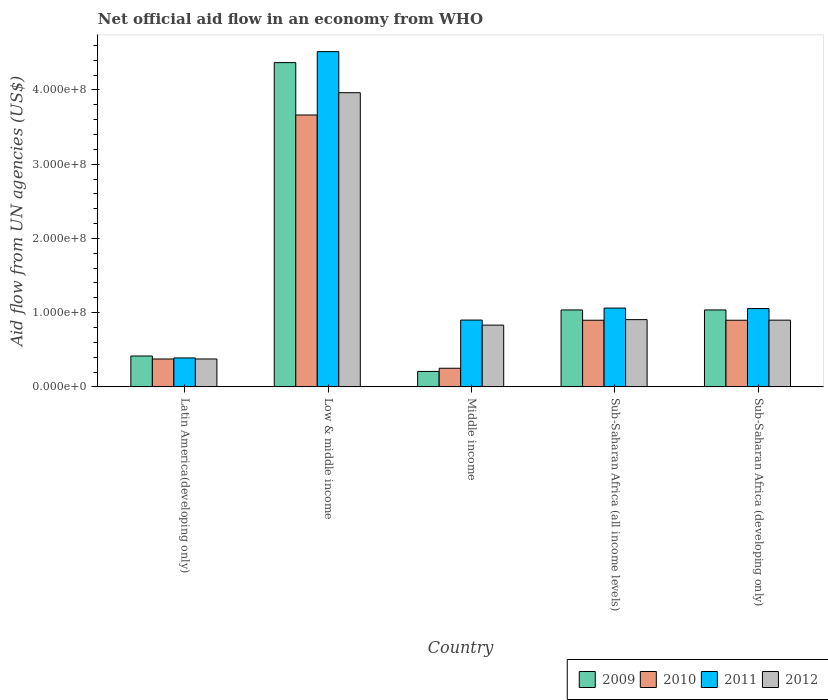Are the number of bars per tick equal to the number of legend labels?
Ensure brevity in your answer.  Yes. Are the number of bars on each tick of the X-axis equal?
Provide a succinct answer. Yes. How many bars are there on the 3rd tick from the left?
Keep it short and to the point. 4. What is the net official aid flow in 2011 in Sub-Saharan Africa (developing only)?
Provide a succinct answer. 1.05e+08. Across all countries, what is the maximum net official aid flow in 2009?
Provide a succinct answer. 4.37e+08. Across all countries, what is the minimum net official aid flow in 2012?
Give a very brief answer. 3.76e+07. In which country was the net official aid flow in 2011 minimum?
Offer a terse response. Latin America(developing only). What is the total net official aid flow in 2009 in the graph?
Provide a short and direct response. 7.06e+08. What is the difference between the net official aid flow in 2010 in Low & middle income and that in Sub-Saharan Africa (developing only)?
Offer a terse response. 2.76e+08. What is the difference between the net official aid flow in 2011 in Latin America(developing only) and the net official aid flow in 2010 in Sub-Saharan Africa (all income levels)?
Provide a succinct answer. -5.08e+07. What is the average net official aid flow in 2012 per country?
Offer a terse response. 1.39e+08. What is the difference between the net official aid flow of/in 2012 and net official aid flow of/in 2011 in Middle income?
Provide a succinct answer. -6.80e+06. What is the ratio of the net official aid flow in 2012 in Latin America(developing only) to that in Sub-Saharan Africa (all income levels)?
Ensure brevity in your answer.  0.41. Is the difference between the net official aid flow in 2012 in Latin America(developing only) and Middle income greater than the difference between the net official aid flow in 2011 in Latin America(developing only) and Middle income?
Your response must be concise. Yes. What is the difference between the highest and the second highest net official aid flow in 2009?
Provide a succinct answer. 3.33e+08. What is the difference between the highest and the lowest net official aid flow in 2011?
Your answer should be very brief. 4.13e+08. Is the sum of the net official aid flow in 2009 in Sub-Saharan Africa (all income levels) and Sub-Saharan Africa (developing only) greater than the maximum net official aid flow in 2011 across all countries?
Your answer should be compact. No. Is it the case that in every country, the sum of the net official aid flow in 2010 and net official aid flow in 2011 is greater than the sum of net official aid flow in 2009 and net official aid flow in 2012?
Provide a short and direct response. No. What does the 3rd bar from the left in Middle income represents?
Your answer should be compact. 2011. Are all the bars in the graph horizontal?
Your response must be concise. No. How many countries are there in the graph?
Provide a succinct answer. 5. Does the graph contain any zero values?
Provide a short and direct response. No. Does the graph contain grids?
Keep it short and to the point. No. How many legend labels are there?
Provide a succinct answer. 4. How are the legend labels stacked?
Provide a short and direct response. Horizontal. What is the title of the graph?
Your answer should be very brief. Net official aid flow in an economy from WHO. What is the label or title of the Y-axis?
Offer a terse response. Aid flow from UN agencies (US$). What is the Aid flow from UN agencies (US$) in 2009 in Latin America(developing only)?
Keep it short and to the point. 4.16e+07. What is the Aid flow from UN agencies (US$) in 2010 in Latin America(developing only)?
Keep it short and to the point. 3.76e+07. What is the Aid flow from UN agencies (US$) in 2011 in Latin America(developing only)?
Offer a terse response. 3.90e+07. What is the Aid flow from UN agencies (US$) in 2012 in Latin America(developing only)?
Offer a terse response. 3.76e+07. What is the Aid flow from UN agencies (US$) of 2009 in Low & middle income?
Your answer should be very brief. 4.37e+08. What is the Aid flow from UN agencies (US$) in 2010 in Low & middle income?
Provide a short and direct response. 3.66e+08. What is the Aid flow from UN agencies (US$) in 2011 in Low & middle income?
Keep it short and to the point. 4.52e+08. What is the Aid flow from UN agencies (US$) of 2012 in Low & middle income?
Ensure brevity in your answer.  3.96e+08. What is the Aid flow from UN agencies (US$) of 2009 in Middle income?
Provide a succinct answer. 2.08e+07. What is the Aid flow from UN agencies (US$) in 2010 in Middle income?
Provide a short and direct response. 2.51e+07. What is the Aid flow from UN agencies (US$) in 2011 in Middle income?
Your response must be concise. 9.00e+07. What is the Aid flow from UN agencies (US$) in 2012 in Middle income?
Offer a very short reply. 8.32e+07. What is the Aid flow from UN agencies (US$) in 2009 in Sub-Saharan Africa (all income levels)?
Make the answer very short. 1.04e+08. What is the Aid flow from UN agencies (US$) in 2010 in Sub-Saharan Africa (all income levels)?
Ensure brevity in your answer.  8.98e+07. What is the Aid flow from UN agencies (US$) in 2011 in Sub-Saharan Africa (all income levels)?
Make the answer very short. 1.06e+08. What is the Aid flow from UN agencies (US$) in 2012 in Sub-Saharan Africa (all income levels)?
Your response must be concise. 9.06e+07. What is the Aid flow from UN agencies (US$) of 2009 in Sub-Saharan Africa (developing only)?
Keep it short and to the point. 1.04e+08. What is the Aid flow from UN agencies (US$) of 2010 in Sub-Saharan Africa (developing only)?
Offer a very short reply. 8.98e+07. What is the Aid flow from UN agencies (US$) of 2011 in Sub-Saharan Africa (developing only)?
Provide a succinct answer. 1.05e+08. What is the Aid flow from UN agencies (US$) in 2012 in Sub-Saharan Africa (developing only)?
Offer a very short reply. 8.98e+07. Across all countries, what is the maximum Aid flow from UN agencies (US$) in 2009?
Provide a succinct answer. 4.37e+08. Across all countries, what is the maximum Aid flow from UN agencies (US$) in 2010?
Keep it short and to the point. 3.66e+08. Across all countries, what is the maximum Aid flow from UN agencies (US$) of 2011?
Your answer should be very brief. 4.52e+08. Across all countries, what is the maximum Aid flow from UN agencies (US$) in 2012?
Offer a very short reply. 3.96e+08. Across all countries, what is the minimum Aid flow from UN agencies (US$) of 2009?
Ensure brevity in your answer.  2.08e+07. Across all countries, what is the minimum Aid flow from UN agencies (US$) of 2010?
Give a very brief answer. 2.51e+07. Across all countries, what is the minimum Aid flow from UN agencies (US$) in 2011?
Give a very brief answer. 3.90e+07. Across all countries, what is the minimum Aid flow from UN agencies (US$) in 2012?
Offer a very short reply. 3.76e+07. What is the total Aid flow from UN agencies (US$) in 2009 in the graph?
Keep it short and to the point. 7.06e+08. What is the total Aid flow from UN agencies (US$) in 2010 in the graph?
Provide a succinct answer. 6.08e+08. What is the total Aid flow from UN agencies (US$) in 2011 in the graph?
Ensure brevity in your answer.  7.92e+08. What is the total Aid flow from UN agencies (US$) of 2012 in the graph?
Give a very brief answer. 6.97e+08. What is the difference between the Aid flow from UN agencies (US$) in 2009 in Latin America(developing only) and that in Low & middle income?
Your answer should be very brief. -3.95e+08. What is the difference between the Aid flow from UN agencies (US$) in 2010 in Latin America(developing only) and that in Low & middle income?
Your answer should be very brief. -3.29e+08. What is the difference between the Aid flow from UN agencies (US$) in 2011 in Latin America(developing only) and that in Low & middle income?
Ensure brevity in your answer.  -4.13e+08. What is the difference between the Aid flow from UN agencies (US$) of 2012 in Latin America(developing only) and that in Low & middle income?
Ensure brevity in your answer.  -3.59e+08. What is the difference between the Aid flow from UN agencies (US$) of 2009 in Latin America(developing only) and that in Middle income?
Give a very brief answer. 2.08e+07. What is the difference between the Aid flow from UN agencies (US$) in 2010 in Latin America(developing only) and that in Middle income?
Your answer should be compact. 1.25e+07. What is the difference between the Aid flow from UN agencies (US$) of 2011 in Latin America(developing only) and that in Middle income?
Provide a succinct answer. -5.10e+07. What is the difference between the Aid flow from UN agencies (US$) of 2012 in Latin America(developing only) and that in Middle income?
Ensure brevity in your answer.  -4.56e+07. What is the difference between the Aid flow from UN agencies (US$) of 2009 in Latin America(developing only) and that in Sub-Saharan Africa (all income levels)?
Your answer should be compact. -6.20e+07. What is the difference between the Aid flow from UN agencies (US$) in 2010 in Latin America(developing only) and that in Sub-Saharan Africa (all income levels)?
Your answer should be very brief. -5.22e+07. What is the difference between the Aid flow from UN agencies (US$) in 2011 in Latin America(developing only) and that in Sub-Saharan Africa (all income levels)?
Provide a succinct answer. -6.72e+07. What is the difference between the Aid flow from UN agencies (US$) in 2012 in Latin America(developing only) and that in Sub-Saharan Africa (all income levels)?
Make the answer very short. -5.30e+07. What is the difference between the Aid flow from UN agencies (US$) in 2009 in Latin America(developing only) and that in Sub-Saharan Africa (developing only)?
Offer a terse response. -6.20e+07. What is the difference between the Aid flow from UN agencies (US$) in 2010 in Latin America(developing only) and that in Sub-Saharan Africa (developing only)?
Your response must be concise. -5.22e+07. What is the difference between the Aid flow from UN agencies (US$) of 2011 in Latin America(developing only) and that in Sub-Saharan Africa (developing only)?
Provide a succinct answer. -6.65e+07. What is the difference between the Aid flow from UN agencies (US$) of 2012 in Latin America(developing only) and that in Sub-Saharan Africa (developing only)?
Provide a succinct answer. -5.23e+07. What is the difference between the Aid flow from UN agencies (US$) in 2009 in Low & middle income and that in Middle income?
Give a very brief answer. 4.16e+08. What is the difference between the Aid flow from UN agencies (US$) of 2010 in Low & middle income and that in Middle income?
Make the answer very short. 3.41e+08. What is the difference between the Aid flow from UN agencies (US$) of 2011 in Low & middle income and that in Middle income?
Your answer should be compact. 3.62e+08. What is the difference between the Aid flow from UN agencies (US$) of 2012 in Low & middle income and that in Middle income?
Your response must be concise. 3.13e+08. What is the difference between the Aid flow from UN agencies (US$) in 2009 in Low & middle income and that in Sub-Saharan Africa (all income levels)?
Your answer should be compact. 3.33e+08. What is the difference between the Aid flow from UN agencies (US$) of 2010 in Low & middle income and that in Sub-Saharan Africa (all income levels)?
Your answer should be compact. 2.76e+08. What is the difference between the Aid flow from UN agencies (US$) in 2011 in Low & middle income and that in Sub-Saharan Africa (all income levels)?
Make the answer very short. 3.45e+08. What is the difference between the Aid flow from UN agencies (US$) in 2012 in Low & middle income and that in Sub-Saharan Africa (all income levels)?
Provide a short and direct response. 3.06e+08. What is the difference between the Aid flow from UN agencies (US$) of 2009 in Low & middle income and that in Sub-Saharan Africa (developing only)?
Offer a terse response. 3.33e+08. What is the difference between the Aid flow from UN agencies (US$) of 2010 in Low & middle income and that in Sub-Saharan Africa (developing only)?
Offer a terse response. 2.76e+08. What is the difference between the Aid flow from UN agencies (US$) of 2011 in Low & middle income and that in Sub-Saharan Africa (developing only)?
Your answer should be very brief. 3.46e+08. What is the difference between the Aid flow from UN agencies (US$) in 2012 in Low & middle income and that in Sub-Saharan Africa (developing only)?
Provide a short and direct response. 3.06e+08. What is the difference between the Aid flow from UN agencies (US$) in 2009 in Middle income and that in Sub-Saharan Africa (all income levels)?
Your response must be concise. -8.28e+07. What is the difference between the Aid flow from UN agencies (US$) in 2010 in Middle income and that in Sub-Saharan Africa (all income levels)?
Offer a terse response. -6.47e+07. What is the difference between the Aid flow from UN agencies (US$) in 2011 in Middle income and that in Sub-Saharan Africa (all income levels)?
Offer a very short reply. -1.62e+07. What is the difference between the Aid flow from UN agencies (US$) in 2012 in Middle income and that in Sub-Saharan Africa (all income levels)?
Your answer should be very brief. -7.39e+06. What is the difference between the Aid flow from UN agencies (US$) of 2009 in Middle income and that in Sub-Saharan Africa (developing only)?
Provide a succinct answer. -8.28e+07. What is the difference between the Aid flow from UN agencies (US$) in 2010 in Middle income and that in Sub-Saharan Africa (developing only)?
Offer a very short reply. -6.47e+07. What is the difference between the Aid flow from UN agencies (US$) of 2011 in Middle income and that in Sub-Saharan Africa (developing only)?
Your answer should be very brief. -1.55e+07. What is the difference between the Aid flow from UN agencies (US$) of 2012 in Middle income and that in Sub-Saharan Africa (developing only)?
Provide a short and direct response. -6.67e+06. What is the difference between the Aid flow from UN agencies (US$) in 2009 in Sub-Saharan Africa (all income levels) and that in Sub-Saharan Africa (developing only)?
Your response must be concise. 0. What is the difference between the Aid flow from UN agencies (US$) in 2010 in Sub-Saharan Africa (all income levels) and that in Sub-Saharan Africa (developing only)?
Give a very brief answer. 0. What is the difference between the Aid flow from UN agencies (US$) in 2011 in Sub-Saharan Africa (all income levels) and that in Sub-Saharan Africa (developing only)?
Your answer should be compact. 6.70e+05. What is the difference between the Aid flow from UN agencies (US$) in 2012 in Sub-Saharan Africa (all income levels) and that in Sub-Saharan Africa (developing only)?
Keep it short and to the point. 7.20e+05. What is the difference between the Aid flow from UN agencies (US$) in 2009 in Latin America(developing only) and the Aid flow from UN agencies (US$) in 2010 in Low & middle income?
Ensure brevity in your answer.  -3.25e+08. What is the difference between the Aid flow from UN agencies (US$) of 2009 in Latin America(developing only) and the Aid flow from UN agencies (US$) of 2011 in Low & middle income?
Ensure brevity in your answer.  -4.10e+08. What is the difference between the Aid flow from UN agencies (US$) of 2009 in Latin America(developing only) and the Aid flow from UN agencies (US$) of 2012 in Low & middle income?
Your answer should be very brief. -3.55e+08. What is the difference between the Aid flow from UN agencies (US$) in 2010 in Latin America(developing only) and the Aid flow from UN agencies (US$) in 2011 in Low & middle income?
Ensure brevity in your answer.  -4.14e+08. What is the difference between the Aid flow from UN agencies (US$) in 2010 in Latin America(developing only) and the Aid flow from UN agencies (US$) in 2012 in Low & middle income?
Make the answer very short. -3.59e+08. What is the difference between the Aid flow from UN agencies (US$) of 2011 in Latin America(developing only) and the Aid flow from UN agencies (US$) of 2012 in Low & middle income?
Ensure brevity in your answer.  -3.57e+08. What is the difference between the Aid flow from UN agencies (US$) in 2009 in Latin America(developing only) and the Aid flow from UN agencies (US$) in 2010 in Middle income?
Give a very brief answer. 1.65e+07. What is the difference between the Aid flow from UN agencies (US$) of 2009 in Latin America(developing only) and the Aid flow from UN agencies (US$) of 2011 in Middle income?
Give a very brief answer. -4.84e+07. What is the difference between the Aid flow from UN agencies (US$) in 2009 in Latin America(developing only) and the Aid flow from UN agencies (US$) in 2012 in Middle income?
Keep it short and to the point. -4.16e+07. What is the difference between the Aid flow from UN agencies (US$) in 2010 in Latin America(developing only) and the Aid flow from UN agencies (US$) in 2011 in Middle income?
Provide a short and direct response. -5.24e+07. What is the difference between the Aid flow from UN agencies (US$) of 2010 in Latin America(developing only) and the Aid flow from UN agencies (US$) of 2012 in Middle income?
Provide a short and direct response. -4.56e+07. What is the difference between the Aid flow from UN agencies (US$) in 2011 in Latin America(developing only) and the Aid flow from UN agencies (US$) in 2012 in Middle income?
Your answer should be compact. -4.42e+07. What is the difference between the Aid flow from UN agencies (US$) of 2009 in Latin America(developing only) and the Aid flow from UN agencies (US$) of 2010 in Sub-Saharan Africa (all income levels)?
Your answer should be compact. -4.82e+07. What is the difference between the Aid flow from UN agencies (US$) in 2009 in Latin America(developing only) and the Aid flow from UN agencies (US$) in 2011 in Sub-Saharan Africa (all income levels)?
Ensure brevity in your answer.  -6.46e+07. What is the difference between the Aid flow from UN agencies (US$) of 2009 in Latin America(developing only) and the Aid flow from UN agencies (US$) of 2012 in Sub-Saharan Africa (all income levels)?
Offer a terse response. -4.90e+07. What is the difference between the Aid flow from UN agencies (US$) in 2010 in Latin America(developing only) and the Aid flow from UN agencies (US$) in 2011 in Sub-Saharan Africa (all income levels)?
Ensure brevity in your answer.  -6.86e+07. What is the difference between the Aid flow from UN agencies (US$) of 2010 in Latin America(developing only) and the Aid flow from UN agencies (US$) of 2012 in Sub-Saharan Africa (all income levels)?
Offer a terse response. -5.30e+07. What is the difference between the Aid flow from UN agencies (US$) of 2011 in Latin America(developing only) and the Aid flow from UN agencies (US$) of 2012 in Sub-Saharan Africa (all income levels)?
Provide a succinct answer. -5.16e+07. What is the difference between the Aid flow from UN agencies (US$) in 2009 in Latin America(developing only) and the Aid flow from UN agencies (US$) in 2010 in Sub-Saharan Africa (developing only)?
Offer a very short reply. -4.82e+07. What is the difference between the Aid flow from UN agencies (US$) of 2009 in Latin America(developing only) and the Aid flow from UN agencies (US$) of 2011 in Sub-Saharan Africa (developing only)?
Offer a terse response. -6.39e+07. What is the difference between the Aid flow from UN agencies (US$) of 2009 in Latin America(developing only) and the Aid flow from UN agencies (US$) of 2012 in Sub-Saharan Africa (developing only)?
Your response must be concise. -4.83e+07. What is the difference between the Aid flow from UN agencies (US$) in 2010 in Latin America(developing only) and the Aid flow from UN agencies (US$) in 2011 in Sub-Saharan Africa (developing only)?
Provide a succinct answer. -6.79e+07. What is the difference between the Aid flow from UN agencies (US$) of 2010 in Latin America(developing only) and the Aid flow from UN agencies (US$) of 2012 in Sub-Saharan Africa (developing only)?
Offer a terse response. -5.23e+07. What is the difference between the Aid flow from UN agencies (US$) in 2011 in Latin America(developing only) and the Aid flow from UN agencies (US$) in 2012 in Sub-Saharan Africa (developing only)?
Ensure brevity in your answer.  -5.09e+07. What is the difference between the Aid flow from UN agencies (US$) in 2009 in Low & middle income and the Aid flow from UN agencies (US$) in 2010 in Middle income?
Provide a succinct answer. 4.12e+08. What is the difference between the Aid flow from UN agencies (US$) of 2009 in Low & middle income and the Aid flow from UN agencies (US$) of 2011 in Middle income?
Provide a succinct answer. 3.47e+08. What is the difference between the Aid flow from UN agencies (US$) in 2009 in Low & middle income and the Aid flow from UN agencies (US$) in 2012 in Middle income?
Your answer should be compact. 3.54e+08. What is the difference between the Aid flow from UN agencies (US$) of 2010 in Low & middle income and the Aid flow from UN agencies (US$) of 2011 in Middle income?
Make the answer very short. 2.76e+08. What is the difference between the Aid flow from UN agencies (US$) in 2010 in Low & middle income and the Aid flow from UN agencies (US$) in 2012 in Middle income?
Offer a very short reply. 2.83e+08. What is the difference between the Aid flow from UN agencies (US$) in 2011 in Low & middle income and the Aid flow from UN agencies (US$) in 2012 in Middle income?
Offer a very short reply. 3.68e+08. What is the difference between the Aid flow from UN agencies (US$) of 2009 in Low & middle income and the Aid flow from UN agencies (US$) of 2010 in Sub-Saharan Africa (all income levels)?
Offer a very short reply. 3.47e+08. What is the difference between the Aid flow from UN agencies (US$) of 2009 in Low & middle income and the Aid flow from UN agencies (US$) of 2011 in Sub-Saharan Africa (all income levels)?
Provide a succinct answer. 3.31e+08. What is the difference between the Aid flow from UN agencies (US$) in 2009 in Low & middle income and the Aid flow from UN agencies (US$) in 2012 in Sub-Saharan Africa (all income levels)?
Provide a short and direct response. 3.46e+08. What is the difference between the Aid flow from UN agencies (US$) of 2010 in Low & middle income and the Aid flow from UN agencies (US$) of 2011 in Sub-Saharan Africa (all income levels)?
Keep it short and to the point. 2.60e+08. What is the difference between the Aid flow from UN agencies (US$) in 2010 in Low & middle income and the Aid flow from UN agencies (US$) in 2012 in Sub-Saharan Africa (all income levels)?
Your response must be concise. 2.76e+08. What is the difference between the Aid flow from UN agencies (US$) of 2011 in Low & middle income and the Aid flow from UN agencies (US$) of 2012 in Sub-Saharan Africa (all income levels)?
Provide a short and direct response. 3.61e+08. What is the difference between the Aid flow from UN agencies (US$) of 2009 in Low & middle income and the Aid flow from UN agencies (US$) of 2010 in Sub-Saharan Africa (developing only)?
Offer a terse response. 3.47e+08. What is the difference between the Aid flow from UN agencies (US$) of 2009 in Low & middle income and the Aid flow from UN agencies (US$) of 2011 in Sub-Saharan Africa (developing only)?
Provide a succinct answer. 3.31e+08. What is the difference between the Aid flow from UN agencies (US$) in 2009 in Low & middle income and the Aid flow from UN agencies (US$) in 2012 in Sub-Saharan Africa (developing only)?
Offer a terse response. 3.47e+08. What is the difference between the Aid flow from UN agencies (US$) in 2010 in Low & middle income and the Aid flow from UN agencies (US$) in 2011 in Sub-Saharan Africa (developing only)?
Your answer should be very brief. 2.61e+08. What is the difference between the Aid flow from UN agencies (US$) of 2010 in Low & middle income and the Aid flow from UN agencies (US$) of 2012 in Sub-Saharan Africa (developing only)?
Offer a very short reply. 2.76e+08. What is the difference between the Aid flow from UN agencies (US$) in 2011 in Low & middle income and the Aid flow from UN agencies (US$) in 2012 in Sub-Saharan Africa (developing only)?
Keep it short and to the point. 3.62e+08. What is the difference between the Aid flow from UN agencies (US$) in 2009 in Middle income and the Aid flow from UN agencies (US$) in 2010 in Sub-Saharan Africa (all income levels)?
Ensure brevity in your answer.  -6.90e+07. What is the difference between the Aid flow from UN agencies (US$) in 2009 in Middle income and the Aid flow from UN agencies (US$) in 2011 in Sub-Saharan Africa (all income levels)?
Provide a short and direct response. -8.54e+07. What is the difference between the Aid flow from UN agencies (US$) in 2009 in Middle income and the Aid flow from UN agencies (US$) in 2012 in Sub-Saharan Africa (all income levels)?
Provide a short and direct response. -6.98e+07. What is the difference between the Aid flow from UN agencies (US$) in 2010 in Middle income and the Aid flow from UN agencies (US$) in 2011 in Sub-Saharan Africa (all income levels)?
Provide a short and direct response. -8.11e+07. What is the difference between the Aid flow from UN agencies (US$) of 2010 in Middle income and the Aid flow from UN agencies (US$) of 2012 in Sub-Saharan Africa (all income levels)?
Your answer should be very brief. -6.55e+07. What is the difference between the Aid flow from UN agencies (US$) of 2011 in Middle income and the Aid flow from UN agencies (US$) of 2012 in Sub-Saharan Africa (all income levels)?
Offer a very short reply. -5.90e+05. What is the difference between the Aid flow from UN agencies (US$) of 2009 in Middle income and the Aid flow from UN agencies (US$) of 2010 in Sub-Saharan Africa (developing only)?
Offer a terse response. -6.90e+07. What is the difference between the Aid flow from UN agencies (US$) in 2009 in Middle income and the Aid flow from UN agencies (US$) in 2011 in Sub-Saharan Africa (developing only)?
Your answer should be compact. -8.47e+07. What is the difference between the Aid flow from UN agencies (US$) of 2009 in Middle income and the Aid flow from UN agencies (US$) of 2012 in Sub-Saharan Africa (developing only)?
Offer a very short reply. -6.90e+07. What is the difference between the Aid flow from UN agencies (US$) of 2010 in Middle income and the Aid flow from UN agencies (US$) of 2011 in Sub-Saharan Africa (developing only)?
Your answer should be compact. -8.04e+07. What is the difference between the Aid flow from UN agencies (US$) of 2010 in Middle income and the Aid flow from UN agencies (US$) of 2012 in Sub-Saharan Africa (developing only)?
Offer a terse response. -6.48e+07. What is the difference between the Aid flow from UN agencies (US$) in 2009 in Sub-Saharan Africa (all income levels) and the Aid flow from UN agencies (US$) in 2010 in Sub-Saharan Africa (developing only)?
Your answer should be compact. 1.39e+07. What is the difference between the Aid flow from UN agencies (US$) in 2009 in Sub-Saharan Africa (all income levels) and the Aid flow from UN agencies (US$) in 2011 in Sub-Saharan Africa (developing only)?
Keep it short and to the point. -1.86e+06. What is the difference between the Aid flow from UN agencies (US$) of 2009 in Sub-Saharan Africa (all income levels) and the Aid flow from UN agencies (US$) of 2012 in Sub-Saharan Africa (developing only)?
Your answer should be very brief. 1.38e+07. What is the difference between the Aid flow from UN agencies (US$) of 2010 in Sub-Saharan Africa (all income levels) and the Aid flow from UN agencies (US$) of 2011 in Sub-Saharan Africa (developing only)?
Provide a succinct answer. -1.57e+07. What is the difference between the Aid flow from UN agencies (US$) of 2010 in Sub-Saharan Africa (all income levels) and the Aid flow from UN agencies (US$) of 2012 in Sub-Saharan Africa (developing only)?
Ensure brevity in your answer.  -9.00e+04. What is the difference between the Aid flow from UN agencies (US$) of 2011 in Sub-Saharan Africa (all income levels) and the Aid flow from UN agencies (US$) of 2012 in Sub-Saharan Africa (developing only)?
Keep it short and to the point. 1.63e+07. What is the average Aid flow from UN agencies (US$) in 2009 per country?
Keep it short and to the point. 1.41e+08. What is the average Aid flow from UN agencies (US$) in 2010 per country?
Provide a short and direct response. 1.22e+08. What is the average Aid flow from UN agencies (US$) of 2011 per country?
Make the answer very short. 1.58e+08. What is the average Aid flow from UN agencies (US$) in 2012 per country?
Offer a terse response. 1.39e+08. What is the difference between the Aid flow from UN agencies (US$) in 2009 and Aid flow from UN agencies (US$) in 2010 in Latin America(developing only)?
Offer a terse response. 4.01e+06. What is the difference between the Aid flow from UN agencies (US$) in 2009 and Aid flow from UN agencies (US$) in 2011 in Latin America(developing only)?
Your answer should be very brief. 2.59e+06. What is the difference between the Aid flow from UN agencies (US$) in 2009 and Aid flow from UN agencies (US$) in 2012 in Latin America(developing only)?
Your response must be concise. 3.99e+06. What is the difference between the Aid flow from UN agencies (US$) of 2010 and Aid flow from UN agencies (US$) of 2011 in Latin America(developing only)?
Provide a succinct answer. -1.42e+06. What is the difference between the Aid flow from UN agencies (US$) of 2010 and Aid flow from UN agencies (US$) of 2012 in Latin America(developing only)?
Provide a succinct answer. -2.00e+04. What is the difference between the Aid flow from UN agencies (US$) of 2011 and Aid flow from UN agencies (US$) of 2012 in Latin America(developing only)?
Make the answer very short. 1.40e+06. What is the difference between the Aid flow from UN agencies (US$) of 2009 and Aid flow from UN agencies (US$) of 2010 in Low & middle income?
Give a very brief answer. 7.06e+07. What is the difference between the Aid flow from UN agencies (US$) in 2009 and Aid flow from UN agencies (US$) in 2011 in Low & middle income?
Give a very brief answer. -1.48e+07. What is the difference between the Aid flow from UN agencies (US$) of 2009 and Aid flow from UN agencies (US$) of 2012 in Low & middle income?
Your answer should be very brief. 4.05e+07. What is the difference between the Aid flow from UN agencies (US$) of 2010 and Aid flow from UN agencies (US$) of 2011 in Low & middle income?
Offer a very short reply. -8.54e+07. What is the difference between the Aid flow from UN agencies (US$) in 2010 and Aid flow from UN agencies (US$) in 2012 in Low & middle income?
Your answer should be compact. -3.00e+07. What is the difference between the Aid flow from UN agencies (US$) in 2011 and Aid flow from UN agencies (US$) in 2012 in Low & middle income?
Give a very brief answer. 5.53e+07. What is the difference between the Aid flow from UN agencies (US$) of 2009 and Aid flow from UN agencies (US$) of 2010 in Middle income?
Your response must be concise. -4.27e+06. What is the difference between the Aid flow from UN agencies (US$) of 2009 and Aid flow from UN agencies (US$) of 2011 in Middle income?
Offer a terse response. -6.92e+07. What is the difference between the Aid flow from UN agencies (US$) of 2009 and Aid flow from UN agencies (US$) of 2012 in Middle income?
Ensure brevity in your answer.  -6.24e+07. What is the difference between the Aid flow from UN agencies (US$) of 2010 and Aid flow from UN agencies (US$) of 2011 in Middle income?
Your answer should be very brief. -6.49e+07. What is the difference between the Aid flow from UN agencies (US$) in 2010 and Aid flow from UN agencies (US$) in 2012 in Middle income?
Your answer should be very brief. -5.81e+07. What is the difference between the Aid flow from UN agencies (US$) of 2011 and Aid flow from UN agencies (US$) of 2012 in Middle income?
Your answer should be very brief. 6.80e+06. What is the difference between the Aid flow from UN agencies (US$) of 2009 and Aid flow from UN agencies (US$) of 2010 in Sub-Saharan Africa (all income levels)?
Your answer should be very brief. 1.39e+07. What is the difference between the Aid flow from UN agencies (US$) of 2009 and Aid flow from UN agencies (US$) of 2011 in Sub-Saharan Africa (all income levels)?
Make the answer very short. -2.53e+06. What is the difference between the Aid flow from UN agencies (US$) in 2009 and Aid flow from UN agencies (US$) in 2012 in Sub-Saharan Africa (all income levels)?
Give a very brief answer. 1.30e+07. What is the difference between the Aid flow from UN agencies (US$) in 2010 and Aid flow from UN agencies (US$) in 2011 in Sub-Saharan Africa (all income levels)?
Provide a short and direct response. -1.64e+07. What is the difference between the Aid flow from UN agencies (US$) of 2010 and Aid flow from UN agencies (US$) of 2012 in Sub-Saharan Africa (all income levels)?
Keep it short and to the point. -8.10e+05. What is the difference between the Aid flow from UN agencies (US$) in 2011 and Aid flow from UN agencies (US$) in 2012 in Sub-Saharan Africa (all income levels)?
Your answer should be very brief. 1.56e+07. What is the difference between the Aid flow from UN agencies (US$) in 2009 and Aid flow from UN agencies (US$) in 2010 in Sub-Saharan Africa (developing only)?
Provide a succinct answer. 1.39e+07. What is the difference between the Aid flow from UN agencies (US$) in 2009 and Aid flow from UN agencies (US$) in 2011 in Sub-Saharan Africa (developing only)?
Your response must be concise. -1.86e+06. What is the difference between the Aid flow from UN agencies (US$) of 2009 and Aid flow from UN agencies (US$) of 2012 in Sub-Saharan Africa (developing only)?
Offer a terse response. 1.38e+07. What is the difference between the Aid flow from UN agencies (US$) in 2010 and Aid flow from UN agencies (US$) in 2011 in Sub-Saharan Africa (developing only)?
Ensure brevity in your answer.  -1.57e+07. What is the difference between the Aid flow from UN agencies (US$) of 2010 and Aid flow from UN agencies (US$) of 2012 in Sub-Saharan Africa (developing only)?
Offer a very short reply. -9.00e+04. What is the difference between the Aid flow from UN agencies (US$) of 2011 and Aid flow from UN agencies (US$) of 2012 in Sub-Saharan Africa (developing only)?
Your response must be concise. 1.56e+07. What is the ratio of the Aid flow from UN agencies (US$) of 2009 in Latin America(developing only) to that in Low & middle income?
Your answer should be very brief. 0.1. What is the ratio of the Aid flow from UN agencies (US$) in 2010 in Latin America(developing only) to that in Low & middle income?
Your answer should be very brief. 0.1. What is the ratio of the Aid flow from UN agencies (US$) of 2011 in Latin America(developing only) to that in Low & middle income?
Give a very brief answer. 0.09. What is the ratio of the Aid flow from UN agencies (US$) in 2012 in Latin America(developing only) to that in Low & middle income?
Provide a succinct answer. 0.09. What is the ratio of the Aid flow from UN agencies (US$) of 2009 in Latin America(developing only) to that in Middle income?
Provide a succinct answer. 2. What is the ratio of the Aid flow from UN agencies (US$) in 2010 in Latin America(developing only) to that in Middle income?
Your response must be concise. 1.5. What is the ratio of the Aid flow from UN agencies (US$) of 2011 in Latin America(developing only) to that in Middle income?
Give a very brief answer. 0.43. What is the ratio of the Aid flow from UN agencies (US$) of 2012 in Latin America(developing only) to that in Middle income?
Your answer should be compact. 0.45. What is the ratio of the Aid flow from UN agencies (US$) in 2009 in Latin America(developing only) to that in Sub-Saharan Africa (all income levels)?
Ensure brevity in your answer.  0.4. What is the ratio of the Aid flow from UN agencies (US$) of 2010 in Latin America(developing only) to that in Sub-Saharan Africa (all income levels)?
Offer a very short reply. 0.42. What is the ratio of the Aid flow from UN agencies (US$) of 2011 in Latin America(developing only) to that in Sub-Saharan Africa (all income levels)?
Provide a short and direct response. 0.37. What is the ratio of the Aid flow from UN agencies (US$) in 2012 in Latin America(developing only) to that in Sub-Saharan Africa (all income levels)?
Keep it short and to the point. 0.41. What is the ratio of the Aid flow from UN agencies (US$) in 2009 in Latin America(developing only) to that in Sub-Saharan Africa (developing only)?
Provide a short and direct response. 0.4. What is the ratio of the Aid flow from UN agencies (US$) of 2010 in Latin America(developing only) to that in Sub-Saharan Africa (developing only)?
Offer a terse response. 0.42. What is the ratio of the Aid flow from UN agencies (US$) in 2011 in Latin America(developing only) to that in Sub-Saharan Africa (developing only)?
Provide a short and direct response. 0.37. What is the ratio of the Aid flow from UN agencies (US$) in 2012 in Latin America(developing only) to that in Sub-Saharan Africa (developing only)?
Ensure brevity in your answer.  0.42. What is the ratio of the Aid flow from UN agencies (US$) in 2009 in Low & middle income to that in Middle income?
Your response must be concise. 21. What is the ratio of the Aid flow from UN agencies (US$) in 2010 in Low & middle income to that in Middle income?
Provide a succinct answer. 14.61. What is the ratio of the Aid flow from UN agencies (US$) of 2011 in Low & middle income to that in Middle income?
Ensure brevity in your answer.  5.02. What is the ratio of the Aid flow from UN agencies (US$) in 2012 in Low & middle income to that in Middle income?
Your answer should be compact. 4.76. What is the ratio of the Aid flow from UN agencies (US$) of 2009 in Low & middle income to that in Sub-Saharan Africa (all income levels)?
Provide a succinct answer. 4.22. What is the ratio of the Aid flow from UN agencies (US$) of 2010 in Low & middle income to that in Sub-Saharan Africa (all income levels)?
Provide a succinct answer. 4.08. What is the ratio of the Aid flow from UN agencies (US$) in 2011 in Low & middle income to that in Sub-Saharan Africa (all income levels)?
Your answer should be very brief. 4.25. What is the ratio of the Aid flow from UN agencies (US$) in 2012 in Low & middle income to that in Sub-Saharan Africa (all income levels)?
Your response must be concise. 4.38. What is the ratio of the Aid flow from UN agencies (US$) of 2009 in Low & middle income to that in Sub-Saharan Africa (developing only)?
Keep it short and to the point. 4.22. What is the ratio of the Aid flow from UN agencies (US$) of 2010 in Low & middle income to that in Sub-Saharan Africa (developing only)?
Provide a succinct answer. 4.08. What is the ratio of the Aid flow from UN agencies (US$) of 2011 in Low & middle income to that in Sub-Saharan Africa (developing only)?
Keep it short and to the point. 4.28. What is the ratio of the Aid flow from UN agencies (US$) in 2012 in Low & middle income to that in Sub-Saharan Africa (developing only)?
Ensure brevity in your answer.  4.41. What is the ratio of the Aid flow from UN agencies (US$) in 2009 in Middle income to that in Sub-Saharan Africa (all income levels)?
Ensure brevity in your answer.  0.2. What is the ratio of the Aid flow from UN agencies (US$) of 2010 in Middle income to that in Sub-Saharan Africa (all income levels)?
Your response must be concise. 0.28. What is the ratio of the Aid flow from UN agencies (US$) in 2011 in Middle income to that in Sub-Saharan Africa (all income levels)?
Provide a succinct answer. 0.85. What is the ratio of the Aid flow from UN agencies (US$) of 2012 in Middle income to that in Sub-Saharan Africa (all income levels)?
Offer a terse response. 0.92. What is the ratio of the Aid flow from UN agencies (US$) in 2009 in Middle income to that in Sub-Saharan Africa (developing only)?
Offer a terse response. 0.2. What is the ratio of the Aid flow from UN agencies (US$) of 2010 in Middle income to that in Sub-Saharan Africa (developing only)?
Give a very brief answer. 0.28. What is the ratio of the Aid flow from UN agencies (US$) of 2011 in Middle income to that in Sub-Saharan Africa (developing only)?
Your answer should be compact. 0.85. What is the ratio of the Aid flow from UN agencies (US$) of 2012 in Middle income to that in Sub-Saharan Africa (developing only)?
Keep it short and to the point. 0.93. What is the ratio of the Aid flow from UN agencies (US$) in 2011 in Sub-Saharan Africa (all income levels) to that in Sub-Saharan Africa (developing only)?
Provide a short and direct response. 1.01. What is the ratio of the Aid flow from UN agencies (US$) in 2012 in Sub-Saharan Africa (all income levels) to that in Sub-Saharan Africa (developing only)?
Provide a succinct answer. 1.01. What is the difference between the highest and the second highest Aid flow from UN agencies (US$) in 2009?
Keep it short and to the point. 3.33e+08. What is the difference between the highest and the second highest Aid flow from UN agencies (US$) in 2010?
Keep it short and to the point. 2.76e+08. What is the difference between the highest and the second highest Aid flow from UN agencies (US$) in 2011?
Your answer should be very brief. 3.45e+08. What is the difference between the highest and the second highest Aid flow from UN agencies (US$) of 2012?
Ensure brevity in your answer.  3.06e+08. What is the difference between the highest and the lowest Aid flow from UN agencies (US$) of 2009?
Offer a very short reply. 4.16e+08. What is the difference between the highest and the lowest Aid flow from UN agencies (US$) in 2010?
Keep it short and to the point. 3.41e+08. What is the difference between the highest and the lowest Aid flow from UN agencies (US$) of 2011?
Your answer should be very brief. 4.13e+08. What is the difference between the highest and the lowest Aid flow from UN agencies (US$) in 2012?
Provide a short and direct response. 3.59e+08. 